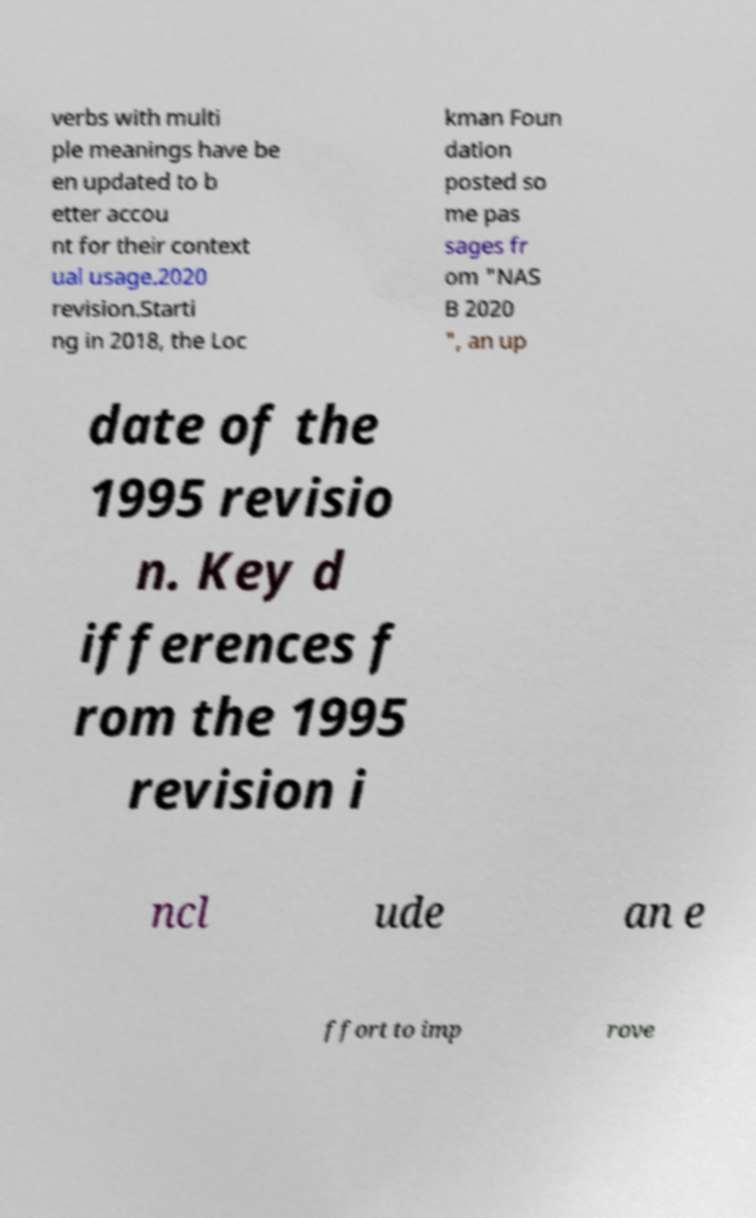What messages or text are displayed in this image? I need them in a readable, typed format. verbs with multi ple meanings have be en updated to b etter accou nt for their context ual usage.2020 revision.Starti ng in 2018, the Loc kman Foun dation posted so me pas sages fr om "NAS B 2020 ", an up date of the 1995 revisio n. Key d ifferences f rom the 1995 revision i ncl ude an e ffort to imp rove 